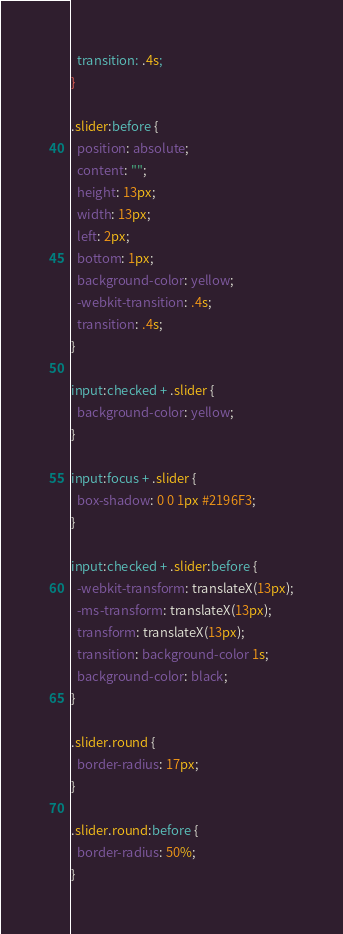<code> <loc_0><loc_0><loc_500><loc_500><_CSS_>  transition: .4s;
}

.slider:before {
  position: absolute;
  content: "";
  height: 13px;
  width: 13px;
  left: 2px;
  bottom: 1px;
  background-color: yellow;
  -webkit-transition: .4s;
  transition: .4s;
}

input:checked + .slider {
  background-color: yellow;
}

input:focus + .slider {
  box-shadow: 0 0 1px #2196F3;
}

input:checked + .slider:before {
  -webkit-transform: translateX(13px);
  -ms-transform: translateX(13px);
  transform: translateX(13px);
  transition: background-color 1s;
  background-color: black;
}

.slider.round {
  border-radius: 17px;
}

.slider.round:before {
  border-radius: 50%;
}
</code> 